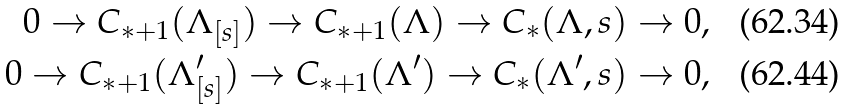<formula> <loc_0><loc_0><loc_500><loc_500>0 \to C _ { * + 1 } ( \Lambda _ { [ s ] } ) \to C _ { * + 1 } ( \Lambda ) \to C _ { * } ( \Lambda , s ) \to 0 , \\ 0 \to C _ { * + 1 } ( \Lambda ^ { \prime } _ { [ s ] } ) \to C _ { * + 1 } ( \Lambda ^ { \prime } ) \to C _ { * } ( \Lambda ^ { \prime } , s ) \to 0 ,</formula> 